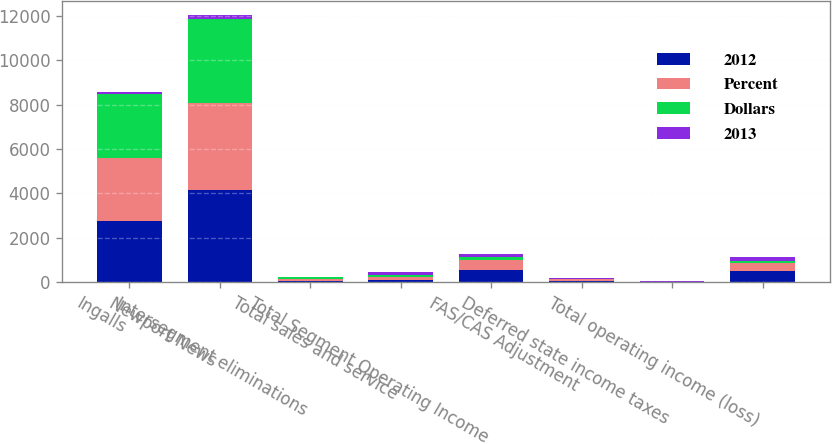Convert chart. <chart><loc_0><loc_0><loc_500><loc_500><stacked_bar_chart><ecel><fcel>Ingalls<fcel>Newport News<fcel>Intersegment eliminations<fcel>Total sales and service<fcel>Total Segment Operating Income<fcel>FAS/CAS Adjustment<fcel>Deferred state income taxes<fcel>Total operating income (loss)<nl><fcel>2012<fcel>2757<fcel>4139<fcel>76<fcel>110<fcel>567<fcel>61<fcel>6<fcel>512<nl><fcel>Percent<fcel>2840<fcel>3940<fcel>72<fcel>110<fcel>457<fcel>80<fcel>19<fcel>358<nl><fcel>Dollars<fcel>2885<fcel>3766<fcel>76<fcel>110<fcel>122<fcel>23<fcel>1<fcel>100<nl><fcel>2013<fcel>83<fcel>199<fcel>4<fcel>112<fcel>110<fcel>19<fcel>25<fcel>154<nl></chart> 